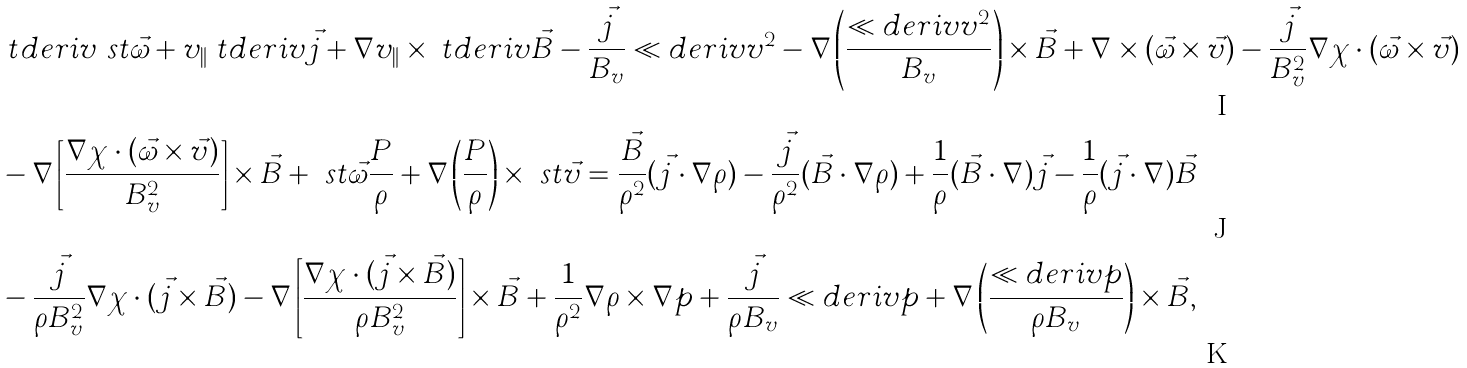Convert formula to latex. <formula><loc_0><loc_0><loc_500><loc_500>& \ t d e r i v { \ s t { \vec { \omega } } } + v _ { \| } \ t d e r i v { \vec { j } } + \nabla v _ { \| } \times \ t d e r i v { \vec { B } } - \frac { \vec { j } } { B _ { v } } \ll d e r i v v ^ { 2 } - \nabla \left ( \frac { \ll d e r i v v ^ { 2 } } { B _ { v } } \right ) \times \vec { B } + \nabla \times ( \vec { \omega } \times \vec { v } ) - \frac { \vec { j } } { B _ { v } ^ { 2 } } \nabla \chi \cdot ( \vec { \omega } \times \vec { v } ) \\ & - \nabla \left [ \frac { \nabla \chi \cdot ( \vec { \omega } \times \vec { v } ) } { B _ { v } ^ { 2 } } \right ] \times \vec { B } + \ s t { \vec { \omega } } \frac { P } { \rho } + \nabla \left ( \frac { P } { \rho } \right ) \times \ s t { \vec { v } } = \frac { \vec { B } } { \rho ^ { 2 } } ( \vec { j } \cdot \nabla \rho ) - \frac { \vec { j } } { \rho ^ { 2 } } ( \vec { B } \cdot \nabla \rho ) + \frac { 1 } { \rho } ( \vec { B } \cdot \nabla ) \vec { j } - \frac { 1 } { \rho } ( \vec { j } \cdot \nabla ) \vec { B } \\ & - \frac { \vec { j } } { \rho B _ { v } ^ { 2 } } \nabla \chi \cdot ( \vec { j } \times \vec { B } ) - \nabla \left [ \frac { \nabla \chi \cdot ( \vec { j } \times \vec { B } ) } { \rho B _ { v } ^ { 2 } } \right ] \times \vec { B } + \frac { 1 } { \rho ^ { 2 } } \nabla \rho \times \nabla p + \frac { \vec { j } } { \rho B _ { v } } \ll d e r i v p + \nabla \left ( \frac { \ll d e r i v p } { \rho B _ { v } } \right ) \times \vec { B } ,</formula> 